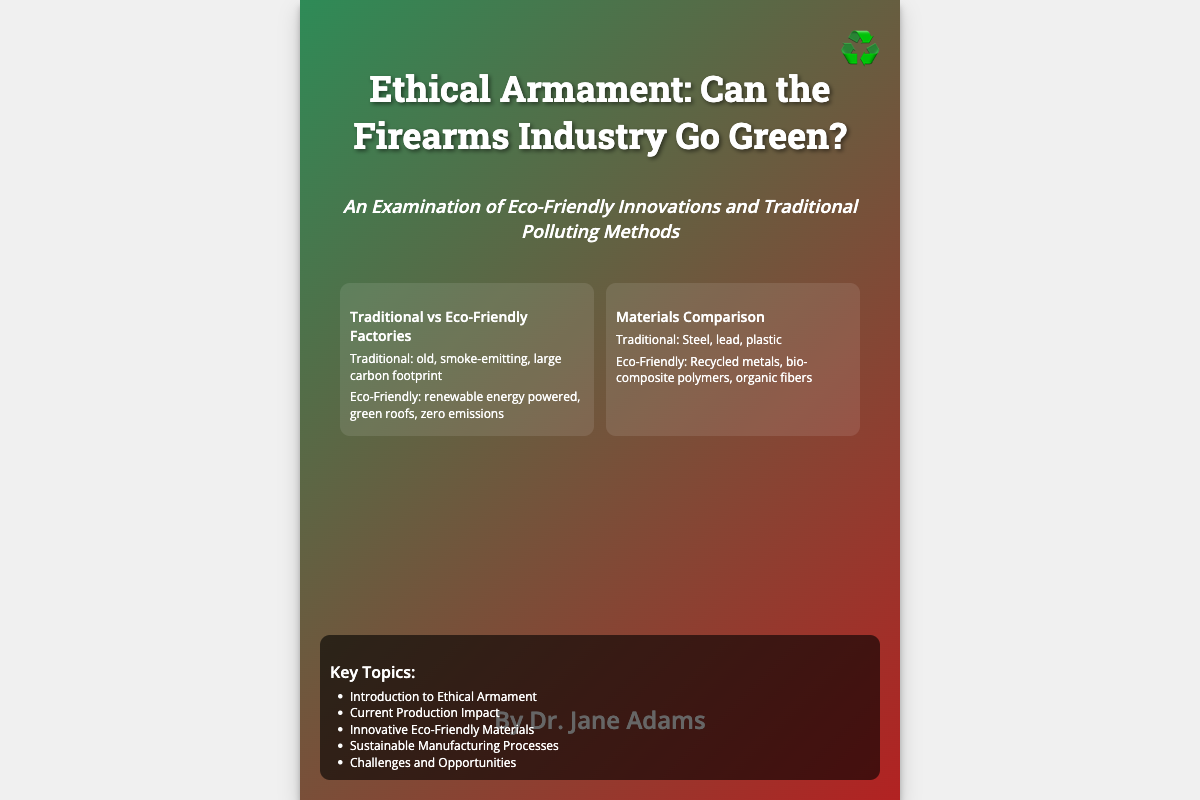What is the title of the book? The title is prominently displayed at the top of the document.
Answer: Ethical Armament: Can the Firearms Industry Go Green? Who is the author of the book? The author name is listed at the bottom of the document.
Answer: Dr. Jane Adams What are the traditional materials mentioned? This information is found in the illustrations section comparing materials.
Answer: Steel, lead, plastic What is one eco-friendly material listed? This information is found in the illustrations section on materials.
Answer: Recycled metals How many illustrations are there? The illustrations section contains a specific number of comparisons.
Answer: Two What are the key topics covered in the book? The key topics are listed in a bullet-point format in the document.
Answer: Introduction to Ethical Armament, Current Production Impact, Innovative Eco-Friendly Materials, Sustainable Manufacturing Processes, Challenges and Opportunities What is the subtitle of the book? The subtitle is directly below the title and is formatted differently.
Answer: An Examination of Eco-Friendly Innovations and Traditional Polluting Methods What is a distinguishing feature of eco-friendly factories? This information is highlighted in the factory comparisons.
Answer: Zero emissions What color theme is used for the book cover? The color gradient background provides this information.
Answer: Green and red 